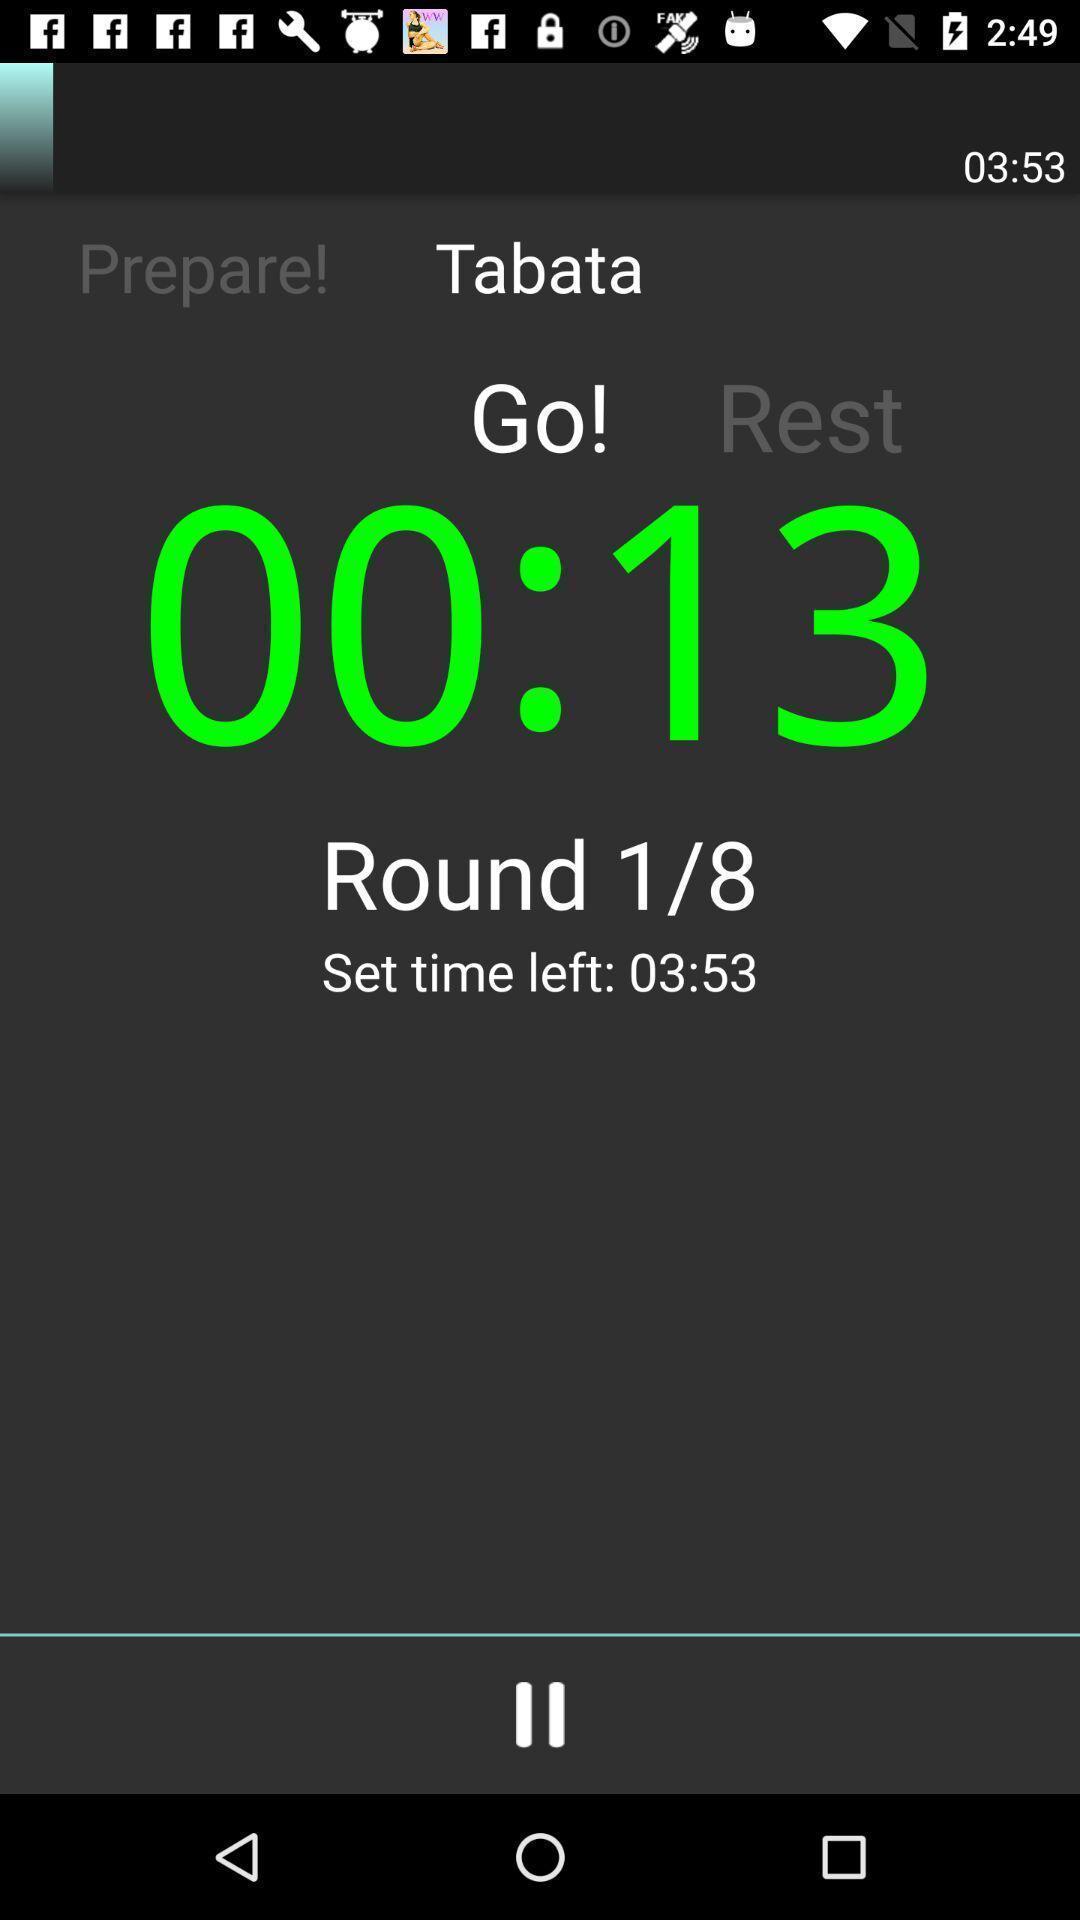Explain what's happening in this screen capture. Screen shows time set. 